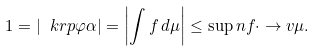Convert formula to latex. <formula><loc_0><loc_0><loc_500><loc_500>1 = | \ k r p \varphi \alpha | = \left | \int f \, d \mu \right | & \leq \sup n f \cdot \to v \mu .</formula> 